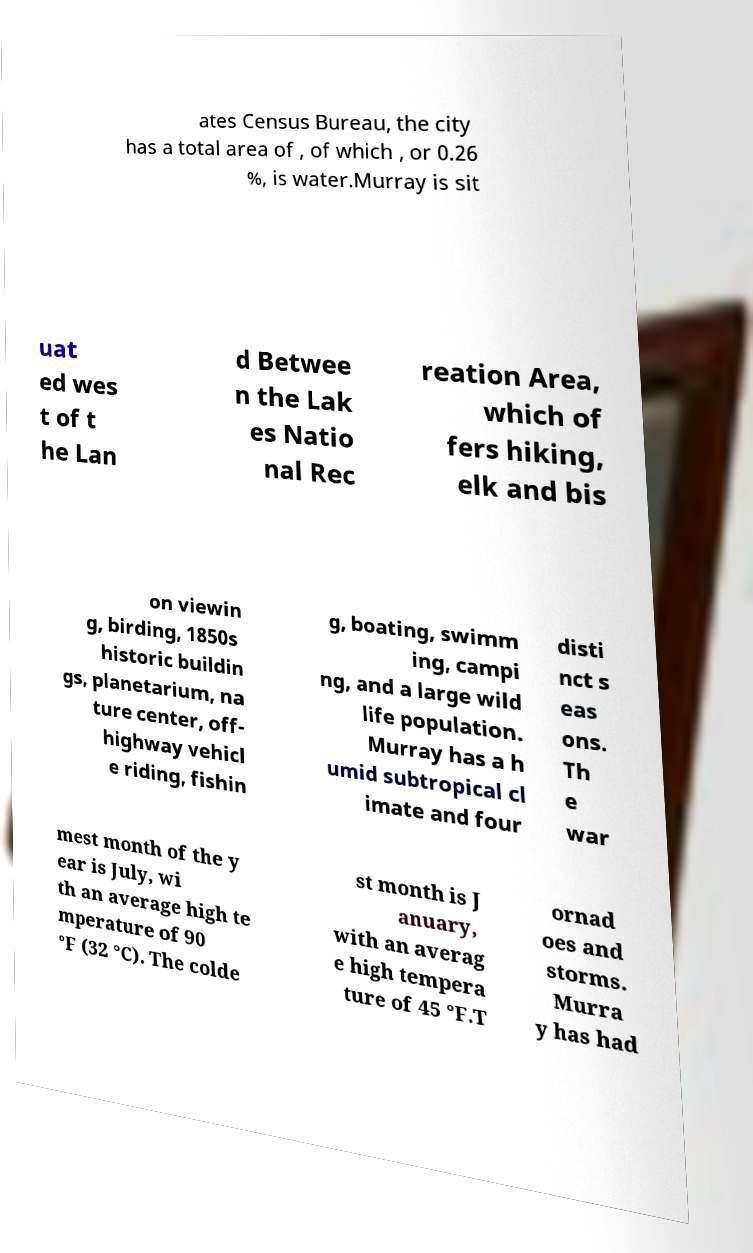Could you extract and type out the text from this image? ates Census Bureau, the city has a total area of , of which , or 0.26 %, is water.Murray is sit uat ed wes t of t he Lan d Betwee n the Lak es Natio nal Rec reation Area, which of fers hiking, elk and bis on viewin g, birding, 1850s historic buildin gs, planetarium, na ture center, off- highway vehicl e riding, fishin g, boating, swimm ing, campi ng, and a large wild life population. Murray has a h umid subtropical cl imate and four disti nct s eas ons. Th e war mest month of the y ear is July, wi th an average high te mperature of 90 °F (32 °C). The colde st month is J anuary, with an averag e high tempera ture of 45 °F.T ornad oes and storms. Murra y has had 